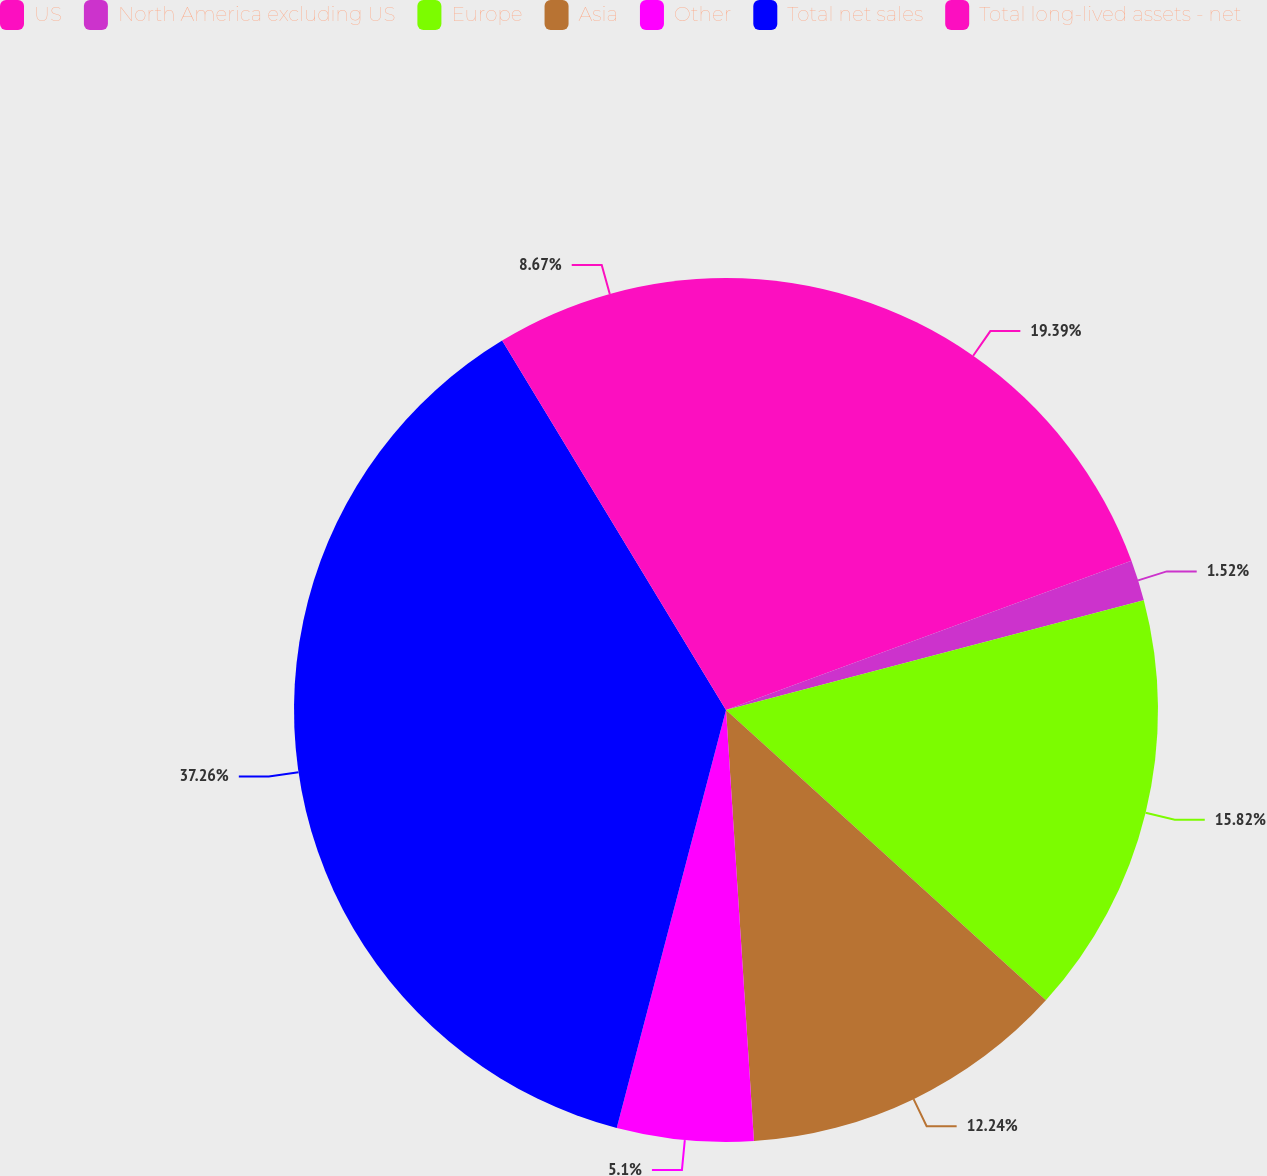Convert chart. <chart><loc_0><loc_0><loc_500><loc_500><pie_chart><fcel>US<fcel>North America excluding US<fcel>Europe<fcel>Asia<fcel>Other<fcel>Total net sales<fcel>Total long-lived assets - net<nl><fcel>19.39%<fcel>1.52%<fcel>15.82%<fcel>12.24%<fcel>5.1%<fcel>37.26%<fcel>8.67%<nl></chart> 